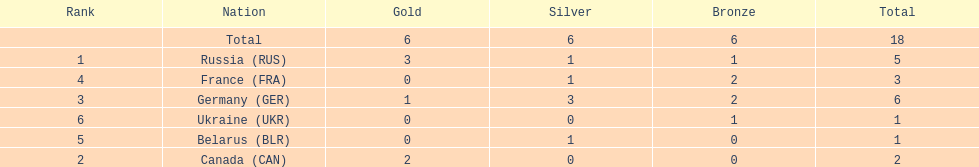What were all the countries that won biathlon medals? Russia (RUS), Canada (CAN), Germany (GER), France (FRA), Belarus (BLR), Ukraine (UKR). What were their medal counts? 5, 2, 6, 3, 1, 1. Of these, which is the largest number of medals? 6. Which country won this number of medals? Germany (GER). 